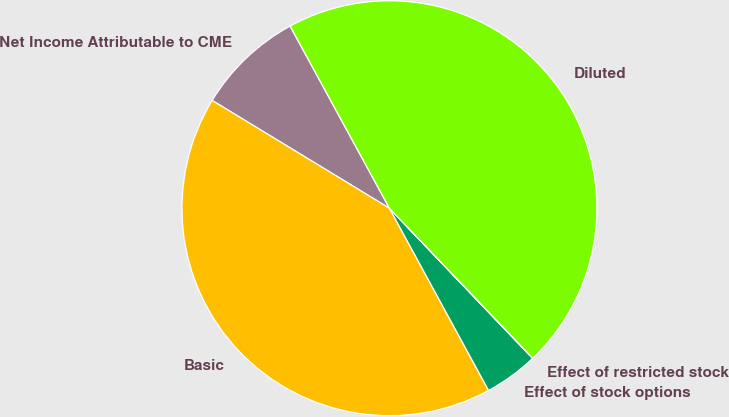Convert chart. <chart><loc_0><loc_0><loc_500><loc_500><pie_chart><fcel>Net Income Attributable to CME<fcel>Basic<fcel>Effect of stock options<fcel>Effect of restricted stock<fcel>Diluted<nl><fcel>8.36%<fcel>41.63%<fcel>4.19%<fcel>0.02%<fcel>45.8%<nl></chart> 